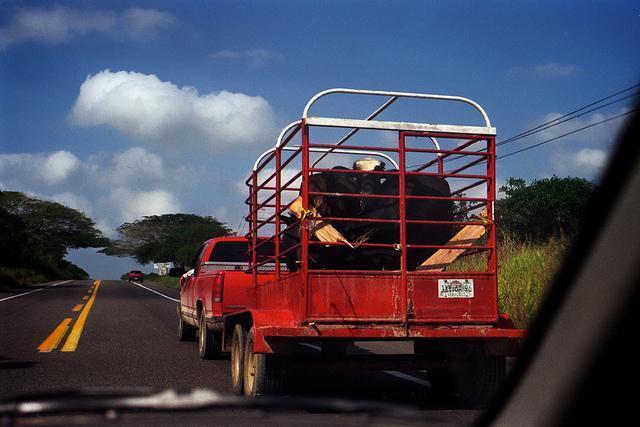How many cows can you see?
Give a very brief answer. 1. How many zebra heads are in the picture?
Give a very brief answer. 0. 